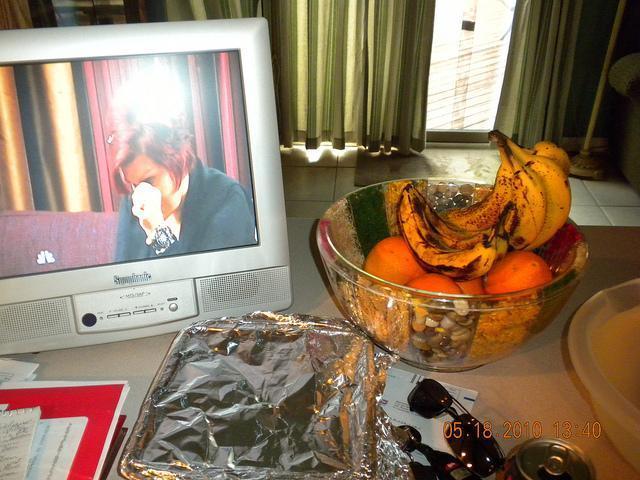How many bananas are visible?
Give a very brief answer. 3. How many bowls are there?
Give a very brief answer. 2. How many trucks are in the picture?
Give a very brief answer. 0. 